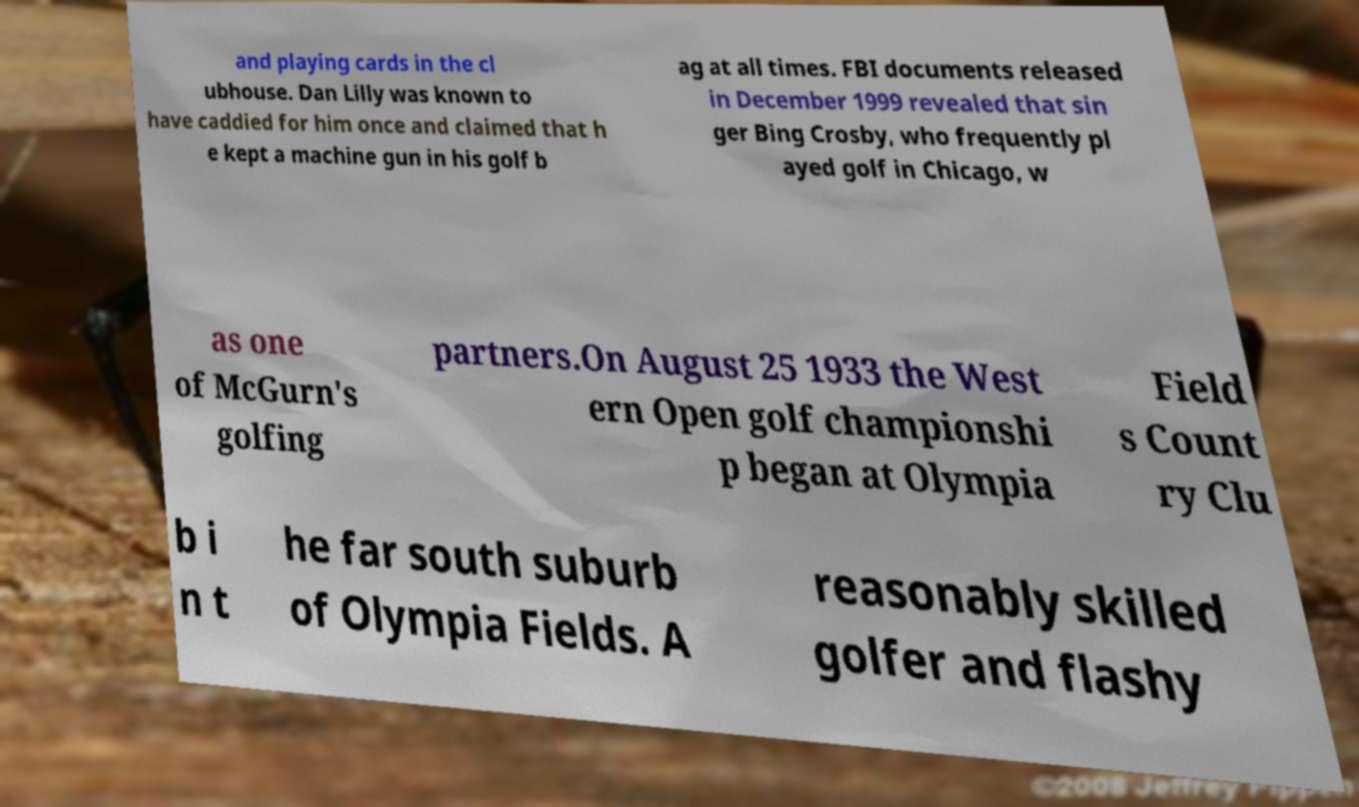Could you extract and type out the text from this image? and playing cards in the cl ubhouse. Dan Lilly was known to have caddied for him once and claimed that h e kept a machine gun in his golf b ag at all times. FBI documents released in December 1999 revealed that sin ger Bing Crosby, who frequently pl ayed golf in Chicago, w as one of McGurn's golfing partners.On August 25 1933 the West ern Open golf championshi p began at Olympia Field s Count ry Clu b i n t he far south suburb of Olympia Fields. A reasonably skilled golfer and flashy 